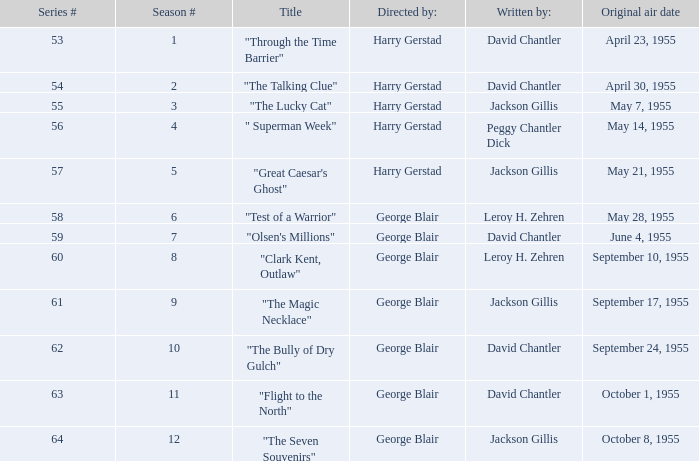Which Season originally aired on September 17, 1955 9.0. 